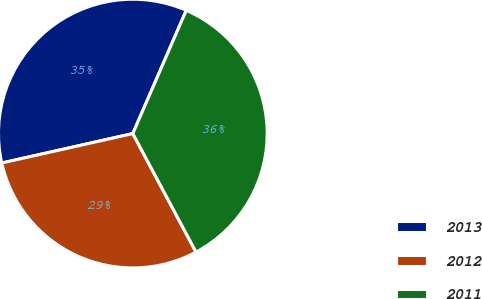<chart> <loc_0><loc_0><loc_500><loc_500><pie_chart><fcel>2013<fcel>2012<fcel>2011<nl><fcel>35.03%<fcel>29.28%<fcel>35.69%<nl></chart> 